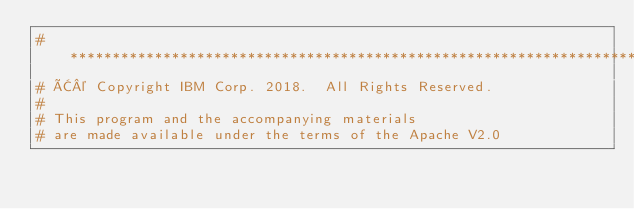<code> <loc_0><loc_0><loc_500><loc_500><_Python_># *****************************************************************************
# Â© Copyright IBM Corp. 2018.  All Rights Reserved.
#
# This program and the accompanying materials
# are made available under the terms of the Apache V2.0</code> 